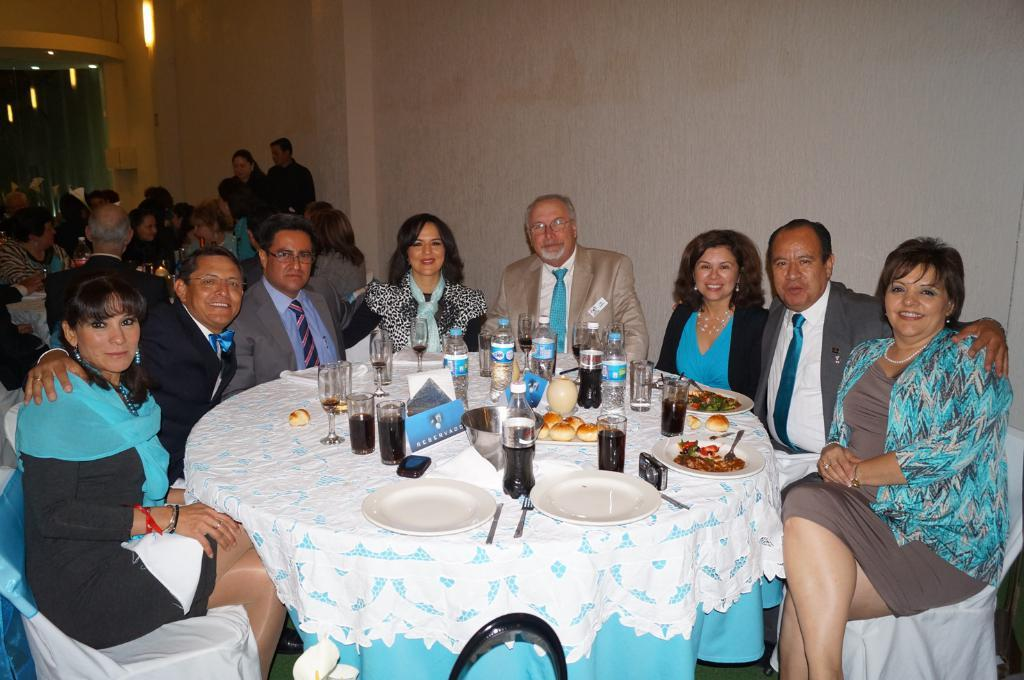How many people are in the image? There is a group of people in the image. What are some of the people in the image doing? Some people are seated on chairs, while others are standing. What objects can be seen on the table in the image? There are glasses, bottles, and plates on the table. What type of can is visible on the table in the image? There is no can present on the table in the image. Is there a lock on the door in the image? There is no door visible in the image, so it is not possible to determine if there is a lock on it. 